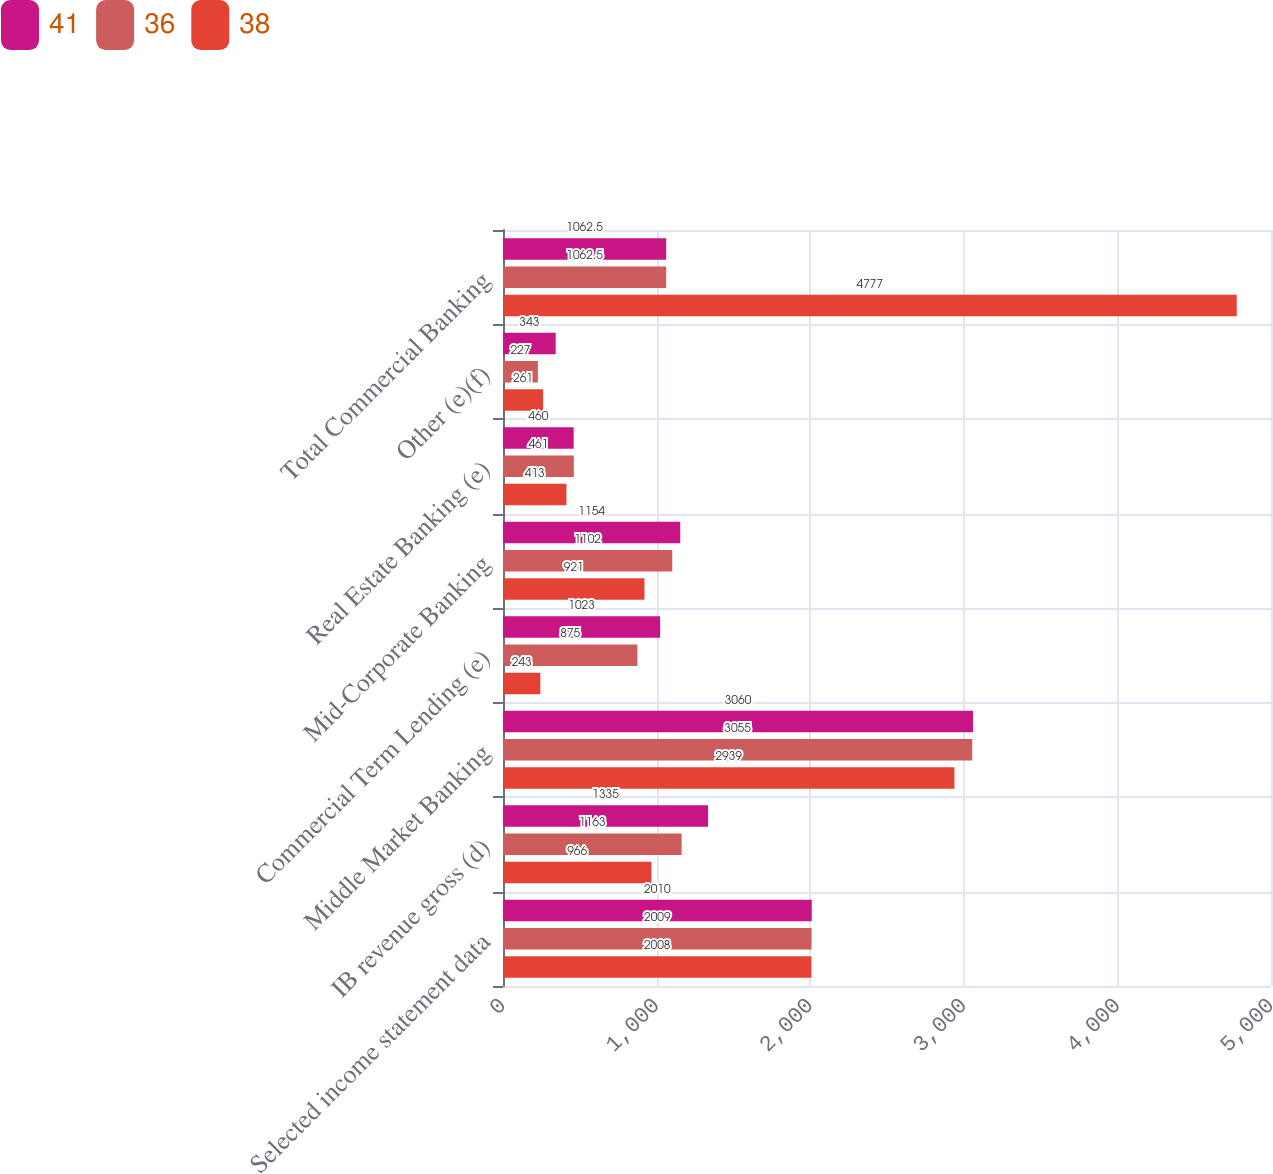<chart> <loc_0><loc_0><loc_500><loc_500><stacked_bar_chart><ecel><fcel>Selected income statement data<fcel>IB revenue gross (d)<fcel>Middle Market Banking<fcel>Commercial Term Lending (e)<fcel>Mid-Corporate Banking<fcel>Real Estate Banking (e)<fcel>Other (e)(f)<fcel>Total Commercial Banking<nl><fcel>41<fcel>2010<fcel>1335<fcel>3060<fcel>1023<fcel>1154<fcel>460<fcel>343<fcel>1062.5<nl><fcel>36<fcel>2009<fcel>1163<fcel>3055<fcel>875<fcel>1102<fcel>461<fcel>227<fcel>1062.5<nl><fcel>38<fcel>2008<fcel>966<fcel>2939<fcel>243<fcel>921<fcel>413<fcel>261<fcel>4777<nl></chart> 